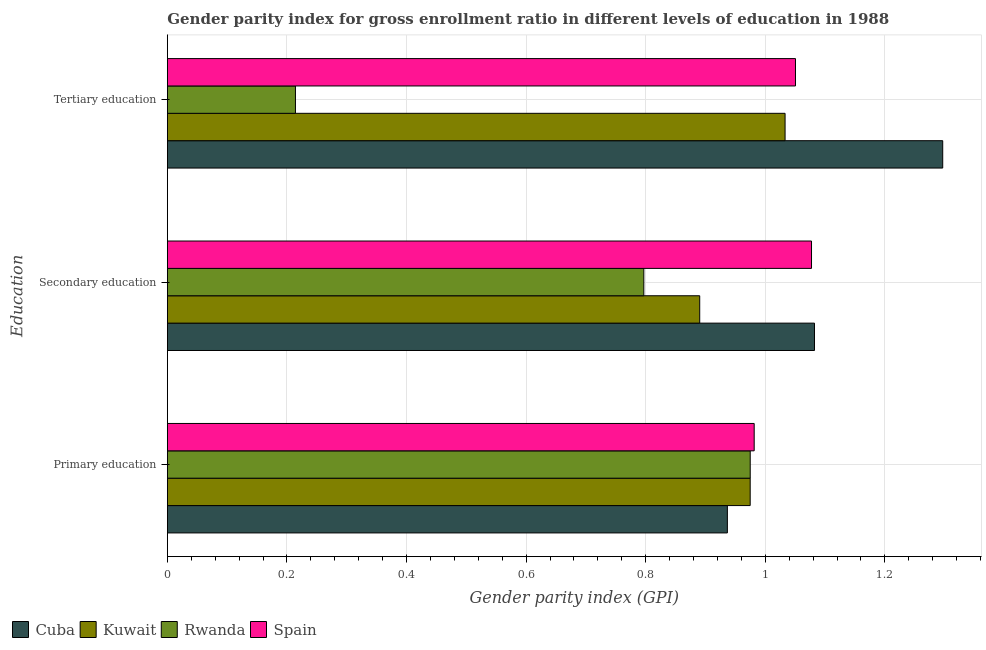Are the number of bars on each tick of the Y-axis equal?
Provide a succinct answer. Yes. How many bars are there on the 3rd tick from the top?
Keep it short and to the point. 4. What is the label of the 1st group of bars from the top?
Provide a succinct answer. Tertiary education. What is the gender parity index in secondary education in Cuba?
Make the answer very short. 1.08. Across all countries, what is the maximum gender parity index in tertiary education?
Your answer should be compact. 1.3. Across all countries, what is the minimum gender parity index in primary education?
Your response must be concise. 0.94. In which country was the gender parity index in tertiary education minimum?
Ensure brevity in your answer.  Rwanda. What is the total gender parity index in secondary education in the graph?
Give a very brief answer. 3.85. What is the difference between the gender parity index in primary education in Cuba and that in Kuwait?
Give a very brief answer. -0.04. What is the difference between the gender parity index in tertiary education in Rwanda and the gender parity index in secondary education in Kuwait?
Offer a very short reply. -0.68. What is the average gender parity index in tertiary education per country?
Keep it short and to the point. 0.9. What is the difference between the gender parity index in secondary education and gender parity index in primary education in Cuba?
Ensure brevity in your answer.  0.15. In how many countries, is the gender parity index in primary education greater than 0.52 ?
Offer a terse response. 4. What is the ratio of the gender parity index in primary education in Rwanda to that in Spain?
Offer a very short reply. 0.99. What is the difference between the highest and the second highest gender parity index in secondary education?
Give a very brief answer. 0. What is the difference between the highest and the lowest gender parity index in secondary education?
Provide a succinct answer. 0.29. What does the 3rd bar from the top in Primary education represents?
Your response must be concise. Kuwait. What does the 2nd bar from the bottom in Secondary education represents?
Provide a short and direct response. Kuwait. How many countries are there in the graph?
Your response must be concise. 4. Are the values on the major ticks of X-axis written in scientific E-notation?
Give a very brief answer. No. Does the graph contain any zero values?
Make the answer very short. No. Does the graph contain grids?
Provide a short and direct response. Yes. How many legend labels are there?
Provide a succinct answer. 4. How are the legend labels stacked?
Keep it short and to the point. Horizontal. What is the title of the graph?
Offer a very short reply. Gender parity index for gross enrollment ratio in different levels of education in 1988. What is the label or title of the X-axis?
Offer a very short reply. Gender parity index (GPI). What is the label or title of the Y-axis?
Provide a short and direct response. Education. What is the Gender parity index (GPI) of Cuba in Primary education?
Provide a succinct answer. 0.94. What is the Gender parity index (GPI) in Kuwait in Primary education?
Provide a succinct answer. 0.97. What is the Gender parity index (GPI) of Rwanda in Primary education?
Provide a short and direct response. 0.97. What is the Gender parity index (GPI) in Spain in Primary education?
Ensure brevity in your answer.  0.98. What is the Gender parity index (GPI) in Cuba in Secondary education?
Provide a succinct answer. 1.08. What is the Gender parity index (GPI) in Kuwait in Secondary education?
Provide a succinct answer. 0.89. What is the Gender parity index (GPI) in Rwanda in Secondary education?
Ensure brevity in your answer.  0.8. What is the Gender parity index (GPI) in Spain in Secondary education?
Make the answer very short. 1.08. What is the Gender parity index (GPI) of Cuba in Tertiary education?
Offer a very short reply. 1.3. What is the Gender parity index (GPI) in Kuwait in Tertiary education?
Give a very brief answer. 1.03. What is the Gender parity index (GPI) of Rwanda in Tertiary education?
Give a very brief answer. 0.21. What is the Gender parity index (GPI) in Spain in Tertiary education?
Offer a very short reply. 1.05. Across all Education, what is the maximum Gender parity index (GPI) in Cuba?
Give a very brief answer. 1.3. Across all Education, what is the maximum Gender parity index (GPI) in Kuwait?
Your answer should be compact. 1.03. Across all Education, what is the maximum Gender parity index (GPI) in Rwanda?
Provide a succinct answer. 0.97. Across all Education, what is the maximum Gender parity index (GPI) of Spain?
Your answer should be compact. 1.08. Across all Education, what is the minimum Gender parity index (GPI) of Cuba?
Keep it short and to the point. 0.94. Across all Education, what is the minimum Gender parity index (GPI) in Kuwait?
Your answer should be very brief. 0.89. Across all Education, what is the minimum Gender parity index (GPI) in Rwanda?
Ensure brevity in your answer.  0.21. Across all Education, what is the minimum Gender parity index (GPI) in Spain?
Your response must be concise. 0.98. What is the total Gender parity index (GPI) of Cuba in the graph?
Offer a terse response. 3.32. What is the total Gender parity index (GPI) in Kuwait in the graph?
Provide a short and direct response. 2.9. What is the total Gender parity index (GPI) in Rwanda in the graph?
Offer a terse response. 1.99. What is the total Gender parity index (GPI) in Spain in the graph?
Your answer should be very brief. 3.11. What is the difference between the Gender parity index (GPI) in Cuba in Primary education and that in Secondary education?
Your answer should be very brief. -0.15. What is the difference between the Gender parity index (GPI) of Kuwait in Primary education and that in Secondary education?
Provide a succinct answer. 0.08. What is the difference between the Gender parity index (GPI) of Rwanda in Primary education and that in Secondary education?
Ensure brevity in your answer.  0.18. What is the difference between the Gender parity index (GPI) of Spain in Primary education and that in Secondary education?
Offer a terse response. -0.1. What is the difference between the Gender parity index (GPI) in Cuba in Primary education and that in Tertiary education?
Make the answer very short. -0.36. What is the difference between the Gender parity index (GPI) in Kuwait in Primary education and that in Tertiary education?
Keep it short and to the point. -0.06. What is the difference between the Gender parity index (GPI) of Rwanda in Primary education and that in Tertiary education?
Give a very brief answer. 0.76. What is the difference between the Gender parity index (GPI) of Spain in Primary education and that in Tertiary education?
Ensure brevity in your answer.  -0.07. What is the difference between the Gender parity index (GPI) of Cuba in Secondary education and that in Tertiary education?
Keep it short and to the point. -0.21. What is the difference between the Gender parity index (GPI) of Kuwait in Secondary education and that in Tertiary education?
Provide a short and direct response. -0.14. What is the difference between the Gender parity index (GPI) of Rwanda in Secondary education and that in Tertiary education?
Ensure brevity in your answer.  0.58. What is the difference between the Gender parity index (GPI) in Spain in Secondary education and that in Tertiary education?
Offer a very short reply. 0.03. What is the difference between the Gender parity index (GPI) of Cuba in Primary education and the Gender parity index (GPI) of Kuwait in Secondary education?
Your answer should be very brief. 0.05. What is the difference between the Gender parity index (GPI) in Cuba in Primary education and the Gender parity index (GPI) in Rwanda in Secondary education?
Offer a very short reply. 0.14. What is the difference between the Gender parity index (GPI) in Cuba in Primary education and the Gender parity index (GPI) in Spain in Secondary education?
Keep it short and to the point. -0.14. What is the difference between the Gender parity index (GPI) of Kuwait in Primary education and the Gender parity index (GPI) of Rwanda in Secondary education?
Provide a succinct answer. 0.18. What is the difference between the Gender parity index (GPI) of Kuwait in Primary education and the Gender parity index (GPI) of Spain in Secondary education?
Your response must be concise. -0.1. What is the difference between the Gender parity index (GPI) in Rwanda in Primary education and the Gender parity index (GPI) in Spain in Secondary education?
Offer a terse response. -0.1. What is the difference between the Gender parity index (GPI) of Cuba in Primary education and the Gender parity index (GPI) of Kuwait in Tertiary education?
Keep it short and to the point. -0.1. What is the difference between the Gender parity index (GPI) of Cuba in Primary education and the Gender parity index (GPI) of Rwanda in Tertiary education?
Your answer should be compact. 0.72. What is the difference between the Gender parity index (GPI) in Cuba in Primary education and the Gender parity index (GPI) in Spain in Tertiary education?
Your answer should be compact. -0.11. What is the difference between the Gender parity index (GPI) in Kuwait in Primary education and the Gender parity index (GPI) in Rwanda in Tertiary education?
Give a very brief answer. 0.76. What is the difference between the Gender parity index (GPI) of Kuwait in Primary education and the Gender parity index (GPI) of Spain in Tertiary education?
Provide a short and direct response. -0.08. What is the difference between the Gender parity index (GPI) of Rwanda in Primary education and the Gender parity index (GPI) of Spain in Tertiary education?
Give a very brief answer. -0.08. What is the difference between the Gender parity index (GPI) of Cuba in Secondary education and the Gender parity index (GPI) of Kuwait in Tertiary education?
Ensure brevity in your answer.  0.05. What is the difference between the Gender parity index (GPI) of Cuba in Secondary education and the Gender parity index (GPI) of Rwanda in Tertiary education?
Your answer should be compact. 0.87. What is the difference between the Gender parity index (GPI) of Cuba in Secondary education and the Gender parity index (GPI) of Spain in Tertiary education?
Make the answer very short. 0.03. What is the difference between the Gender parity index (GPI) of Kuwait in Secondary education and the Gender parity index (GPI) of Rwanda in Tertiary education?
Provide a succinct answer. 0.68. What is the difference between the Gender parity index (GPI) in Kuwait in Secondary education and the Gender parity index (GPI) in Spain in Tertiary education?
Make the answer very short. -0.16. What is the difference between the Gender parity index (GPI) of Rwanda in Secondary education and the Gender parity index (GPI) of Spain in Tertiary education?
Provide a succinct answer. -0.25. What is the average Gender parity index (GPI) of Cuba per Education?
Give a very brief answer. 1.11. What is the average Gender parity index (GPI) of Rwanda per Education?
Ensure brevity in your answer.  0.66. What is the average Gender parity index (GPI) of Spain per Education?
Provide a short and direct response. 1.04. What is the difference between the Gender parity index (GPI) of Cuba and Gender parity index (GPI) of Kuwait in Primary education?
Offer a terse response. -0.04. What is the difference between the Gender parity index (GPI) of Cuba and Gender parity index (GPI) of Rwanda in Primary education?
Make the answer very short. -0.04. What is the difference between the Gender parity index (GPI) in Cuba and Gender parity index (GPI) in Spain in Primary education?
Your answer should be very brief. -0.04. What is the difference between the Gender parity index (GPI) in Kuwait and Gender parity index (GPI) in Spain in Primary education?
Your answer should be compact. -0.01. What is the difference between the Gender parity index (GPI) in Rwanda and Gender parity index (GPI) in Spain in Primary education?
Your response must be concise. -0.01. What is the difference between the Gender parity index (GPI) of Cuba and Gender parity index (GPI) of Kuwait in Secondary education?
Provide a short and direct response. 0.19. What is the difference between the Gender parity index (GPI) of Cuba and Gender parity index (GPI) of Rwanda in Secondary education?
Your response must be concise. 0.29. What is the difference between the Gender parity index (GPI) in Cuba and Gender parity index (GPI) in Spain in Secondary education?
Ensure brevity in your answer.  0.01. What is the difference between the Gender parity index (GPI) of Kuwait and Gender parity index (GPI) of Rwanda in Secondary education?
Your answer should be very brief. 0.09. What is the difference between the Gender parity index (GPI) in Kuwait and Gender parity index (GPI) in Spain in Secondary education?
Your answer should be compact. -0.19. What is the difference between the Gender parity index (GPI) in Rwanda and Gender parity index (GPI) in Spain in Secondary education?
Offer a very short reply. -0.28. What is the difference between the Gender parity index (GPI) of Cuba and Gender parity index (GPI) of Kuwait in Tertiary education?
Your response must be concise. 0.26. What is the difference between the Gender parity index (GPI) of Cuba and Gender parity index (GPI) of Rwanda in Tertiary education?
Provide a short and direct response. 1.08. What is the difference between the Gender parity index (GPI) of Cuba and Gender parity index (GPI) of Spain in Tertiary education?
Your answer should be very brief. 0.25. What is the difference between the Gender parity index (GPI) of Kuwait and Gender parity index (GPI) of Rwanda in Tertiary education?
Provide a succinct answer. 0.82. What is the difference between the Gender parity index (GPI) in Kuwait and Gender parity index (GPI) in Spain in Tertiary education?
Keep it short and to the point. -0.02. What is the difference between the Gender parity index (GPI) of Rwanda and Gender parity index (GPI) of Spain in Tertiary education?
Give a very brief answer. -0.84. What is the ratio of the Gender parity index (GPI) of Cuba in Primary education to that in Secondary education?
Offer a terse response. 0.87. What is the ratio of the Gender parity index (GPI) in Kuwait in Primary education to that in Secondary education?
Offer a terse response. 1.09. What is the ratio of the Gender parity index (GPI) in Rwanda in Primary education to that in Secondary education?
Your answer should be very brief. 1.22. What is the ratio of the Gender parity index (GPI) of Spain in Primary education to that in Secondary education?
Your answer should be very brief. 0.91. What is the ratio of the Gender parity index (GPI) of Cuba in Primary education to that in Tertiary education?
Your answer should be compact. 0.72. What is the ratio of the Gender parity index (GPI) in Kuwait in Primary education to that in Tertiary education?
Offer a terse response. 0.94. What is the ratio of the Gender parity index (GPI) in Rwanda in Primary education to that in Tertiary education?
Provide a short and direct response. 4.55. What is the ratio of the Gender parity index (GPI) in Spain in Primary education to that in Tertiary education?
Your answer should be compact. 0.93. What is the ratio of the Gender parity index (GPI) of Cuba in Secondary education to that in Tertiary education?
Provide a short and direct response. 0.83. What is the ratio of the Gender parity index (GPI) of Kuwait in Secondary education to that in Tertiary education?
Provide a short and direct response. 0.86. What is the ratio of the Gender parity index (GPI) of Rwanda in Secondary education to that in Tertiary education?
Offer a very short reply. 3.72. What is the ratio of the Gender parity index (GPI) of Spain in Secondary education to that in Tertiary education?
Give a very brief answer. 1.03. What is the difference between the highest and the second highest Gender parity index (GPI) of Cuba?
Give a very brief answer. 0.21. What is the difference between the highest and the second highest Gender parity index (GPI) of Kuwait?
Give a very brief answer. 0.06. What is the difference between the highest and the second highest Gender parity index (GPI) in Rwanda?
Offer a terse response. 0.18. What is the difference between the highest and the second highest Gender parity index (GPI) of Spain?
Offer a terse response. 0.03. What is the difference between the highest and the lowest Gender parity index (GPI) in Cuba?
Your answer should be compact. 0.36. What is the difference between the highest and the lowest Gender parity index (GPI) of Kuwait?
Your response must be concise. 0.14. What is the difference between the highest and the lowest Gender parity index (GPI) in Rwanda?
Your answer should be very brief. 0.76. What is the difference between the highest and the lowest Gender parity index (GPI) in Spain?
Keep it short and to the point. 0.1. 